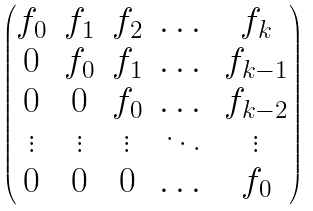Convert formula to latex. <formula><loc_0><loc_0><loc_500><loc_500>\begin{pmatrix} f _ { 0 } & f _ { 1 } & f _ { 2 } & \dots & f _ { k } \\ 0 & f _ { 0 } & f _ { 1 } & \dots & f _ { k - 1 } \\ 0 & 0 & f _ { 0 } & \dots & f _ { k - 2 } \\ \vdots & \vdots & \vdots & \ddots & \vdots \\ 0 & 0 & 0 & \dots & f _ { 0 } \end{pmatrix}</formula> 